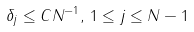Convert formula to latex. <formula><loc_0><loc_0><loc_500><loc_500>\delta _ { j } \leq C N ^ { - 1 } , \, 1 \leq j \leq N - 1</formula> 